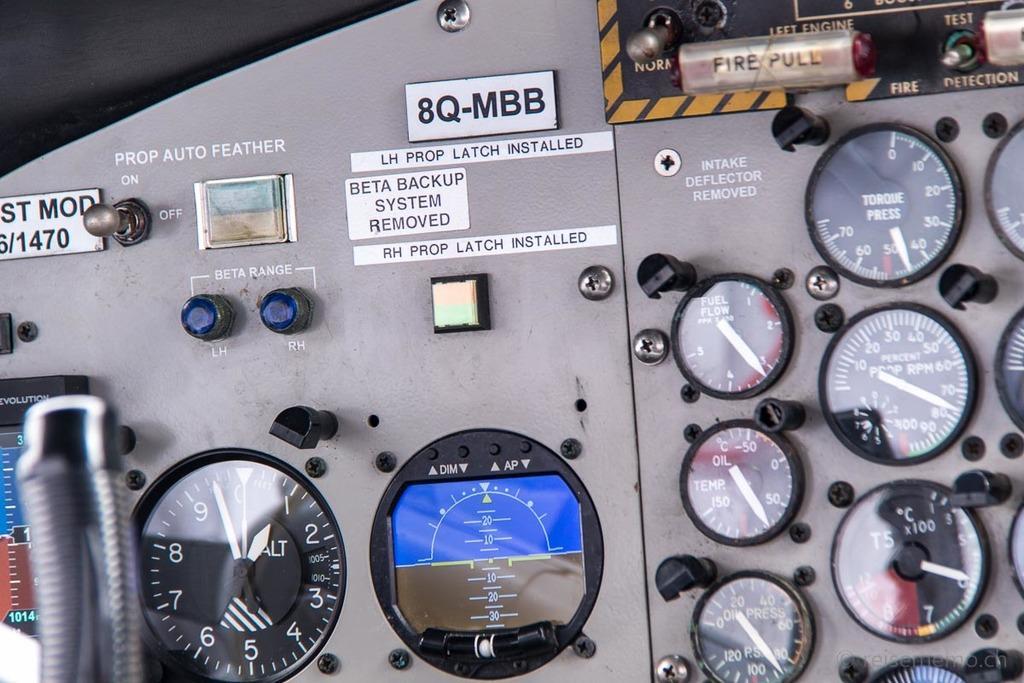Can you describe this image briefly? In the image on the board there are many meters. And also there are nuts, switches, lights and a few other items. And on the board there is something written on it. There is a meter with screen. 